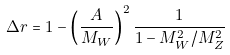<formula> <loc_0><loc_0><loc_500><loc_500>\Delta r = 1 - \left ( \frac { A } { M _ { W } } \right ) ^ { 2 } \frac { 1 } { 1 - M _ { W } ^ { 2 } / M _ { Z } ^ { 2 } }</formula> 